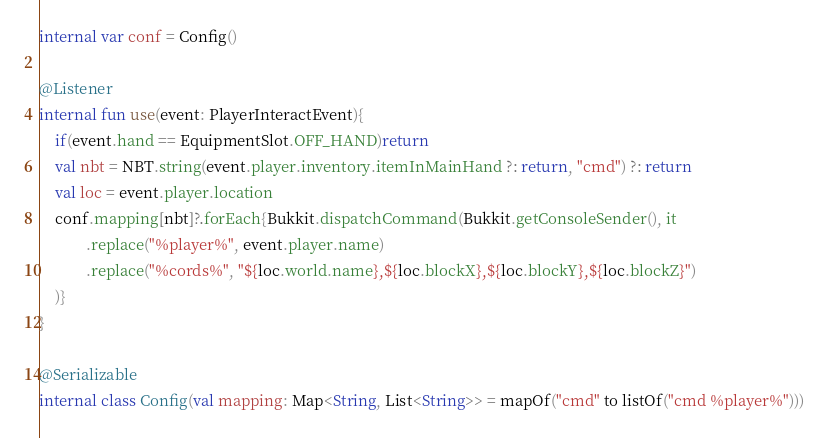<code> <loc_0><loc_0><loc_500><loc_500><_Kotlin_>internal var conf = Config()

@Listener
internal fun use(event: PlayerInteractEvent){
    if(event.hand == EquipmentSlot.OFF_HAND)return
    val nbt = NBT.string(event.player.inventory.itemInMainHand ?: return, "cmd") ?: return
    val loc = event.player.location
    conf.mapping[nbt]?.forEach{Bukkit.dispatchCommand(Bukkit.getConsoleSender(), it
            .replace("%player%", event.player.name)
            .replace("%cords%", "${loc.world.name},${loc.blockX},${loc.blockY},${loc.blockZ}")
    )}
}

@Serializable
internal class Config(val mapping: Map<String, List<String>> = mapOf("cmd" to listOf("cmd %player%")))</code> 